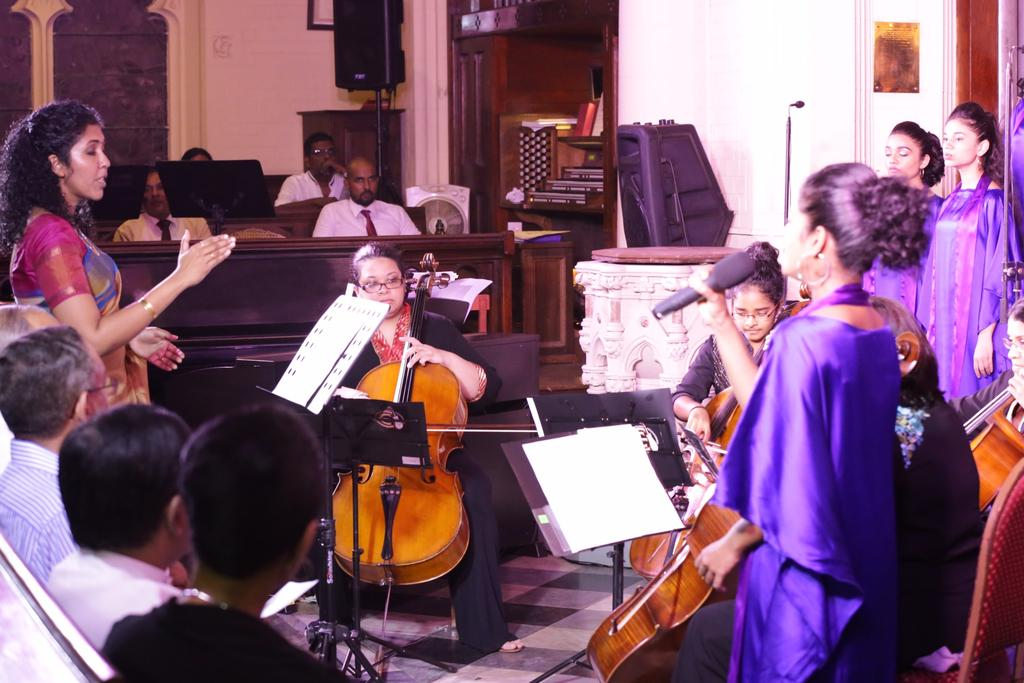What type of group is performing in the image? There is a band of women in the image. What are the women in the band doing? The women are playing music, and one woman is singing while some provide chorus. Are there any spectators in the image? Yes, there are people watching the band. How many tomatoes are being used by the band in the image? There are no tomatoes present in the image; the band is playing music and singing. Can you tell me which toe the lead singer is using to hold the microphone? There is no information about the toes of the band members in the image, as they are focused on playing music and singing. 